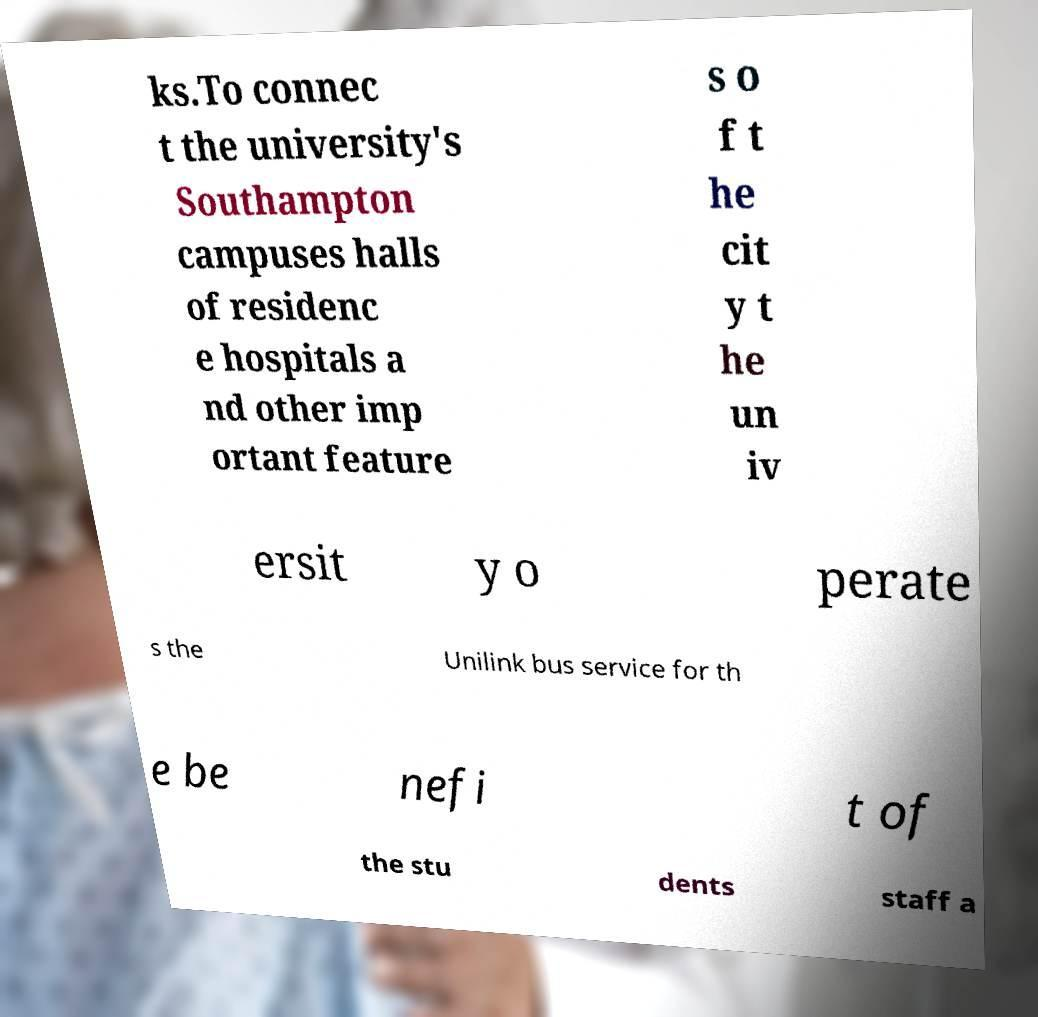What messages or text are displayed in this image? I need them in a readable, typed format. ks.To connec t the university's Southampton campuses halls of residenc e hospitals a nd other imp ortant feature s o f t he cit y t he un iv ersit y o perate s the Unilink bus service for th e be nefi t of the stu dents staff a 